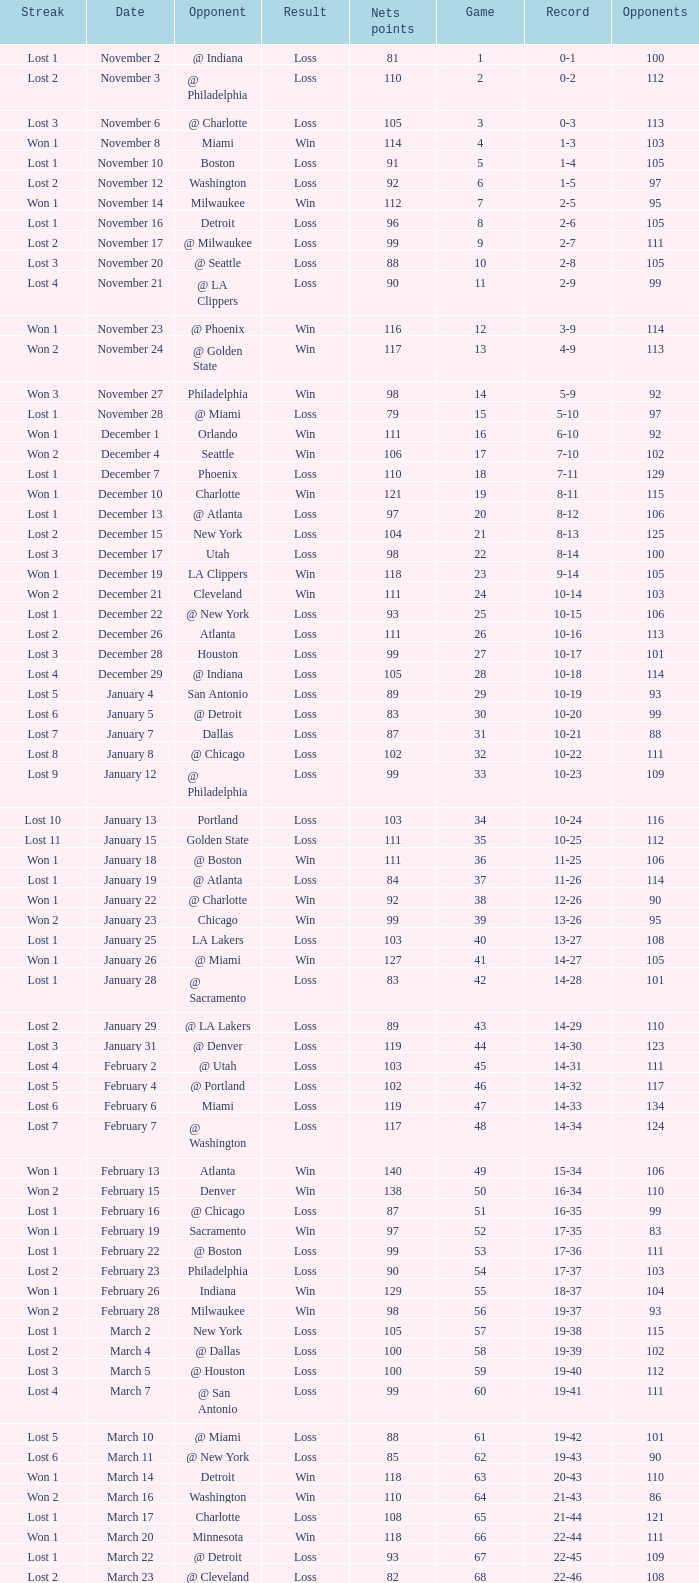In which game did the opponent score more than 103 and the record was 1-3? None. 